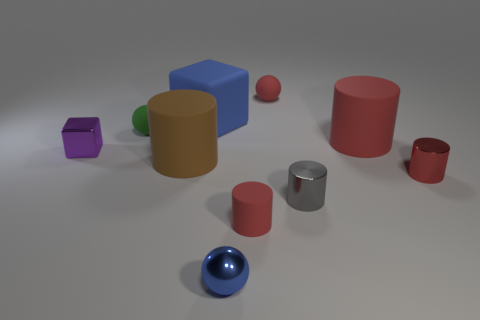What colors are predominant in the objects I can see in this picture? The objects in the picture display a variety of colors, with blue, red, green, and purple being the most prominent among them. How many objects are there, and can you describe their shapes? I can identify nine objects, which include a blue cuboid, a large red cylinder, a small red cylinder, a green sphere, a purple hexagonal prism, a small red cuboid, a tan cuboid, a small silver cylinder, and a blue sphere. 